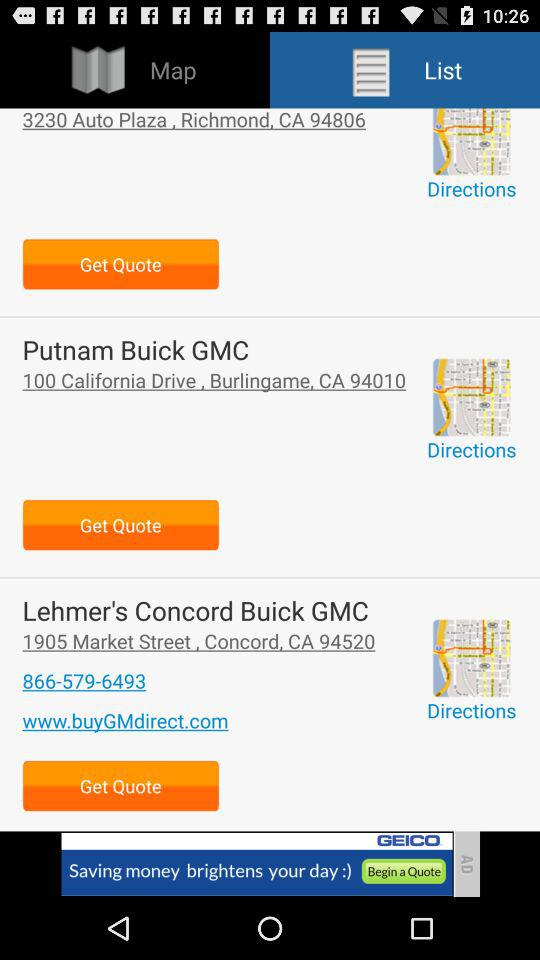What is the address of "Putnam Buick GMC"? The address of "Putnam Buick GMC" is 100 California Drive, Burlingame, CA 94010. 